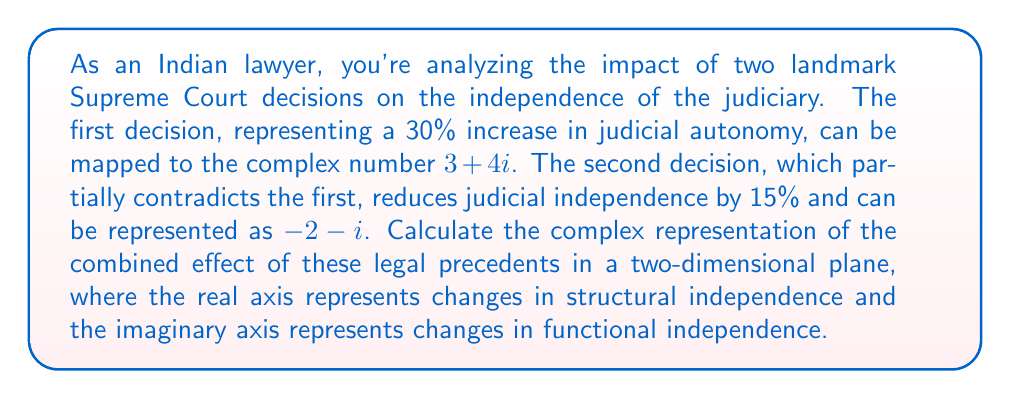Help me with this question. To solve this problem, we need to add the two complex numbers representing the legal precedents:

1) First precedent: $z_1 = 3 + 4i$
2) Second precedent: $z_2 = -2 - i$

The combined effect is the sum of these complex numbers:

$$z_{total} = z_1 + z_2 = (3 + 4i) + (-2 - i)$$

We add the real and imaginary parts separately:

Real part: $3 + (-2) = 1$
Imaginary part: $4i + (-i) = 3i$

Therefore, the combined effect is:

$$z_{total} = 1 + 3i$$

This result can be interpreted as follows:
- The real part (1) indicates a net 10% increase in structural independence of the judiciary.
- The imaginary part (3i) represents a 30% increase in functional independence of the judiciary.

The magnitude of this complex number, which represents the overall change in judicial independence, can be calculated using the formula $\sqrt{a^2 + b^2}$:

$$\sqrt{1^2 + 3^2} = \sqrt{10} \approx 3.16$$

This suggests an overall increase of approximately 31.6% in judicial independence.

The angle of this complex number, which represents the balance between structural and functional changes, can be calculated using $\arctan(\frac{b}{a})$:

$$\theta = \arctan(\frac{3}{1}) \approx 71.57°$$

This angle indicates that the changes lean more towards functional independence than structural independence.
Answer: The complex representation of the combined effect of the legal precedents is $1 + 3i$, indicating a 10% increase in structural independence and a 30% increase in functional independence of the judiciary. 